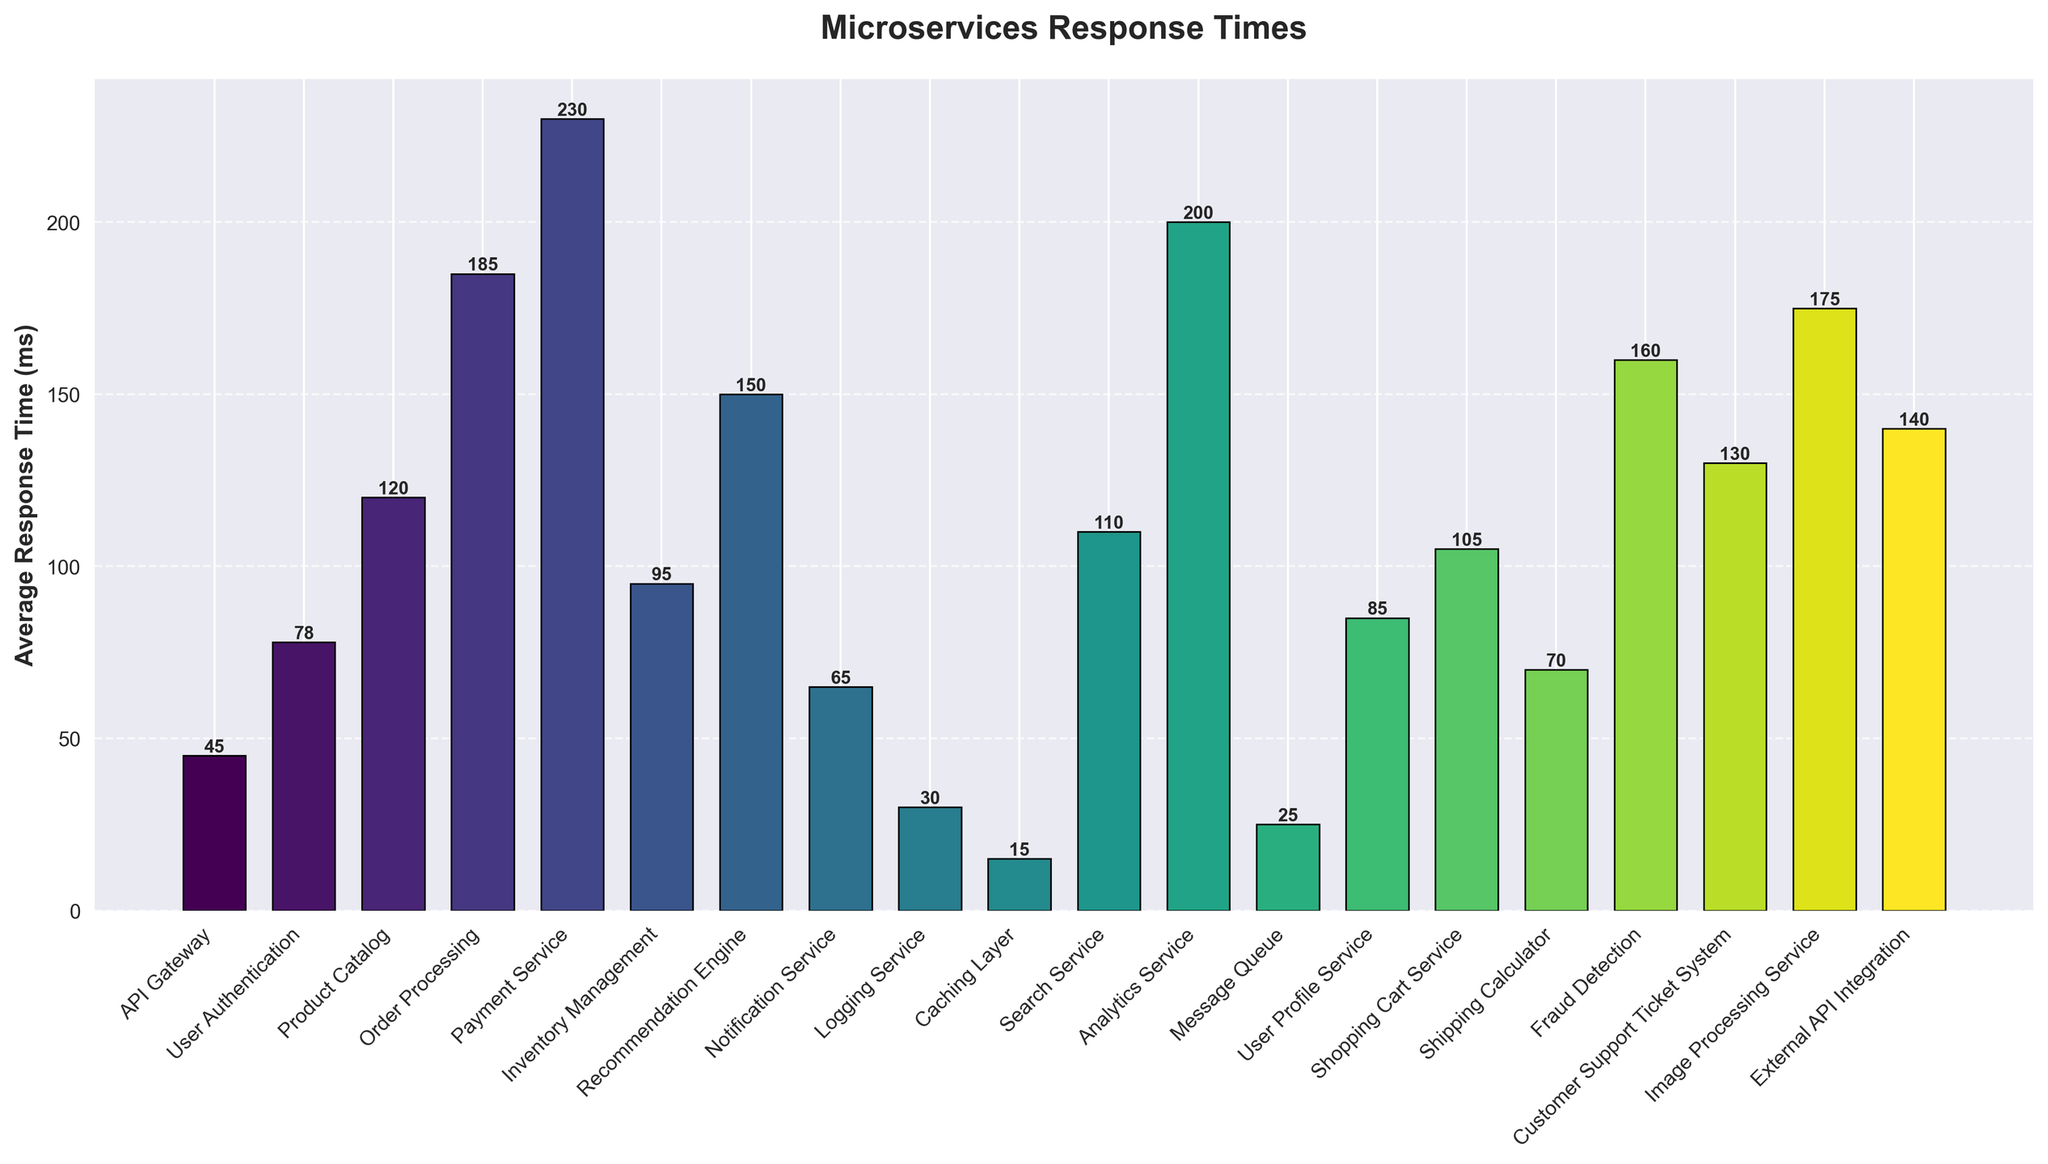Which service type has the highest average response time? First, we look for the tallest bar in the bar chart. The tallest bar represents the Payment Service with an average response time of 230 ms.
Answer: Payment Service Which service types have average response times greater than 150 ms? Identify the bars with heights above 150 ms. The following service types have average response times above 150 ms: Order Processing, Analytics Service, Image Processing Service, Fraud Detection, and Payment Service.
Answer: Order Processing, Analytics Service, Image Processing Service, Fraud Detection, Payment Service Which service type has the lowest average response time? Look for the shortest bar in the bar chart. The shortest bar represents the Caching Layer with an average response time of 15 ms.
Answer: Caching Layer What is the difference in average response time between the Inventory Management and User Profile Service? Locate the bars for Inventory Management and User Profile Service. Inventory Management has 95 ms, and User Profile Service has 85 ms. The difference is 95 ms - 85 ms = 10 ms.
Answer: 10 ms Which service type is faster, Search Service or Shopping Cart Service? By how much? Compare the heights of the bars for Search Service and Shopping Cart Service. Search Service has 110 ms while Shopping Cart Service has 105 ms. Shopping Cart Service is faster by 110 ms - 105 ms = 5 ms.
Answer: Shopping Cart Service, 5 ms What is the combined average response time for the API Gateway, User Authentication, and Notification Service? Sum the response times of API Gateway (45 ms), User Authentication (78 ms), and Notification Service (65 ms). Combined: 45 ms + 78 ms + 65 ms = 188 ms.
Answer: 188 ms Which category has a visual attribute corresponding to a vibrant greenish color? Observing the color spectrum used in the chart, the vibrant greenish color appears around the middle section. The Recommendation Engine, with 150 ms response time, corresponds to this color.
Answer: Recommendation Engine What is the average response time for services related to user interactions (User Authentication, User Profile Service, Shopping Cart Service)? Sum the response times of User Authentication (78 ms), User Profile Service (85 ms), and Shopping Cart Service (105 ms). Total is 78 ms + 85 ms + 105 ms = 268 ms. Divide by the number of services (3). Average is 268 ms / 3 ≈ 89.33 ms.
Answer: 89.33 ms Which service types have an average response time less than 50 ms? Identify the bars with heights below 50 ms. These service types are: Caching Layer (15 ms), Logging Service (30 ms), Message Queue (25 ms), and API Gateway (45 ms).
Answer: Caching Layer, Logging Service, Message Queue, API Gateway 